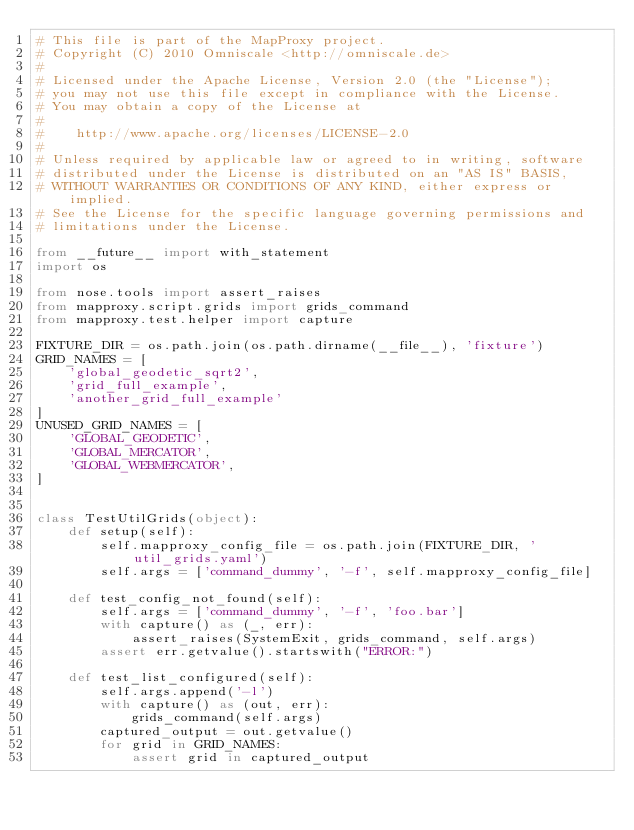<code> <loc_0><loc_0><loc_500><loc_500><_Python_># This file is part of the MapProxy project.
# Copyright (C) 2010 Omniscale <http://omniscale.de>
#
# Licensed under the Apache License, Version 2.0 (the "License");
# you may not use this file except in compliance with the License.
# You may obtain a copy of the License at
#
#    http://www.apache.org/licenses/LICENSE-2.0
#
# Unless required by applicable law or agreed to in writing, software
# distributed under the License is distributed on an "AS IS" BASIS,
# WITHOUT WARRANTIES OR CONDITIONS OF ANY KIND, either express or implied.
# See the License for the specific language governing permissions and
# limitations under the License.

from __future__ import with_statement
import os

from nose.tools import assert_raises
from mapproxy.script.grids import grids_command
from mapproxy.test.helper import capture

FIXTURE_DIR = os.path.join(os.path.dirname(__file__), 'fixture')
GRID_NAMES = [
    'global_geodetic_sqrt2',
    'grid_full_example',
    'another_grid_full_example'
]
UNUSED_GRID_NAMES = [
    'GLOBAL_GEODETIC',
    'GLOBAL_MERCATOR',
    'GLOBAL_WEBMERCATOR',
]


class TestUtilGrids(object):
    def setup(self):
        self.mapproxy_config_file = os.path.join(FIXTURE_DIR, 'util_grids.yaml')
        self.args = ['command_dummy', '-f', self.mapproxy_config_file]

    def test_config_not_found(self):
        self.args = ['command_dummy', '-f', 'foo.bar']
        with capture() as (_, err):
            assert_raises(SystemExit, grids_command, self.args)
        assert err.getvalue().startswith("ERROR:")

    def test_list_configured(self):
        self.args.append('-l')
        with capture() as (out, err):
            grids_command(self.args)
        captured_output = out.getvalue()
        for grid in GRID_NAMES:
            assert grid in captured_output
</code> 